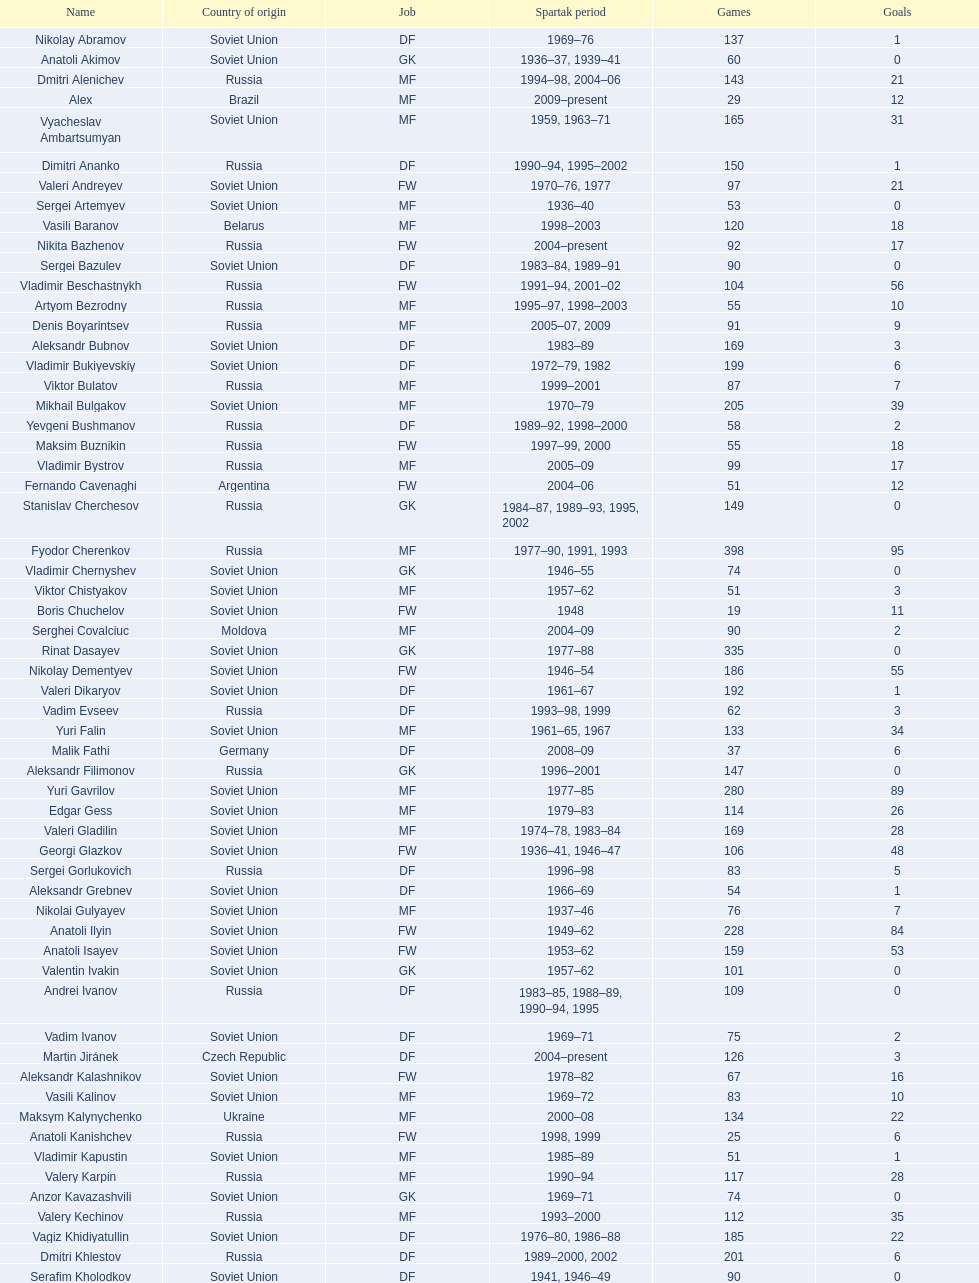Name two players with goals above 15. Dmitri Alenichev, Vyacheslav Ambartsumyan. 